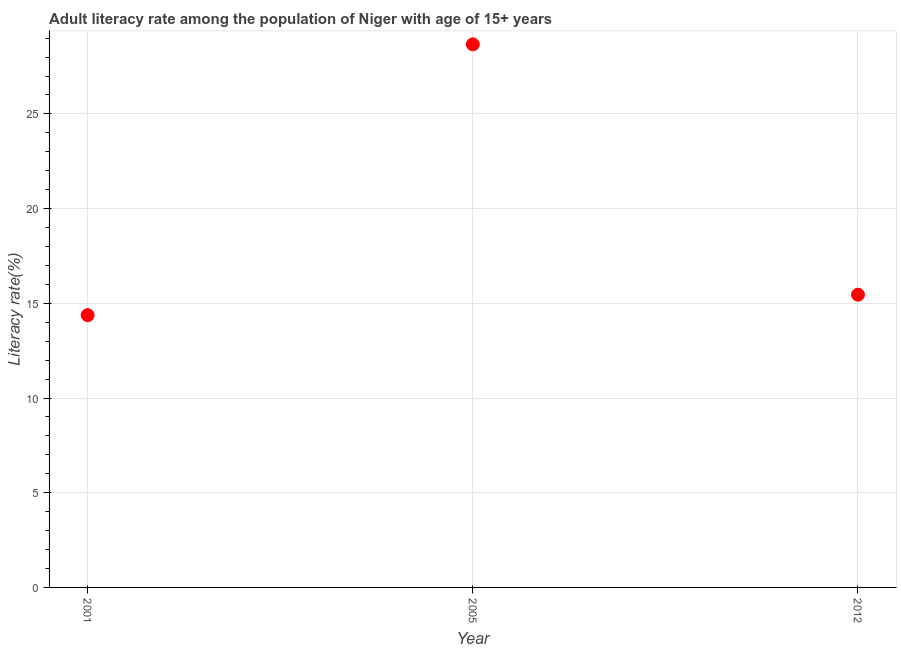What is the adult literacy rate in 2001?
Offer a terse response. 14.38. Across all years, what is the maximum adult literacy rate?
Make the answer very short. 28.67. Across all years, what is the minimum adult literacy rate?
Offer a very short reply. 14.38. In which year was the adult literacy rate minimum?
Offer a very short reply. 2001. What is the sum of the adult literacy rate?
Keep it short and to the point. 58.51. What is the difference between the adult literacy rate in 2001 and 2005?
Keep it short and to the point. -14.3. What is the average adult literacy rate per year?
Provide a succinct answer. 19.5. What is the median adult literacy rate?
Offer a terse response. 15.46. Do a majority of the years between 2012 and 2001 (inclusive) have adult literacy rate greater than 25 %?
Offer a very short reply. No. What is the ratio of the adult literacy rate in 2005 to that in 2012?
Offer a terse response. 1.86. What is the difference between the highest and the second highest adult literacy rate?
Your response must be concise. 13.22. Is the sum of the adult literacy rate in 2005 and 2012 greater than the maximum adult literacy rate across all years?
Your answer should be compact. Yes. What is the difference between the highest and the lowest adult literacy rate?
Keep it short and to the point. 14.3. In how many years, is the adult literacy rate greater than the average adult literacy rate taken over all years?
Keep it short and to the point. 1. How many dotlines are there?
Make the answer very short. 1. How many years are there in the graph?
Provide a succinct answer. 3. What is the difference between two consecutive major ticks on the Y-axis?
Give a very brief answer. 5. Are the values on the major ticks of Y-axis written in scientific E-notation?
Provide a short and direct response. No. What is the title of the graph?
Keep it short and to the point. Adult literacy rate among the population of Niger with age of 15+ years. What is the label or title of the Y-axis?
Provide a short and direct response. Literacy rate(%). What is the Literacy rate(%) in 2001?
Make the answer very short. 14.38. What is the Literacy rate(%) in 2005?
Give a very brief answer. 28.67. What is the Literacy rate(%) in 2012?
Give a very brief answer. 15.46. What is the difference between the Literacy rate(%) in 2001 and 2005?
Keep it short and to the point. -14.3. What is the difference between the Literacy rate(%) in 2001 and 2012?
Offer a terse response. -1.08. What is the difference between the Literacy rate(%) in 2005 and 2012?
Give a very brief answer. 13.22. What is the ratio of the Literacy rate(%) in 2001 to that in 2005?
Keep it short and to the point. 0.5. What is the ratio of the Literacy rate(%) in 2001 to that in 2012?
Your answer should be very brief. 0.93. What is the ratio of the Literacy rate(%) in 2005 to that in 2012?
Offer a very short reply. 1.85. 